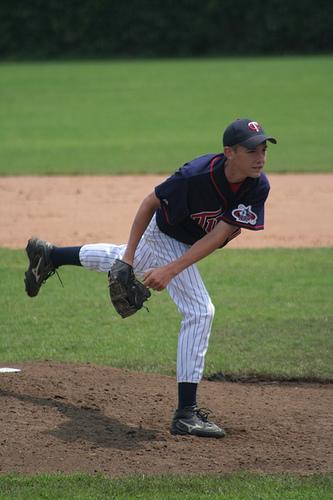In what direction will the ball travel when the pitcher releases the ball?
Concise answer only. Forward. What is this man's position?
Quick response, please. Pitcher. Is his uniform red?
Answer briefly. No. What color are his socks?
Write a very short answer. Black. Is this person pitching a ball?
Be succinct. Yes. What sport is this?
Concise answer only. Baseball. 